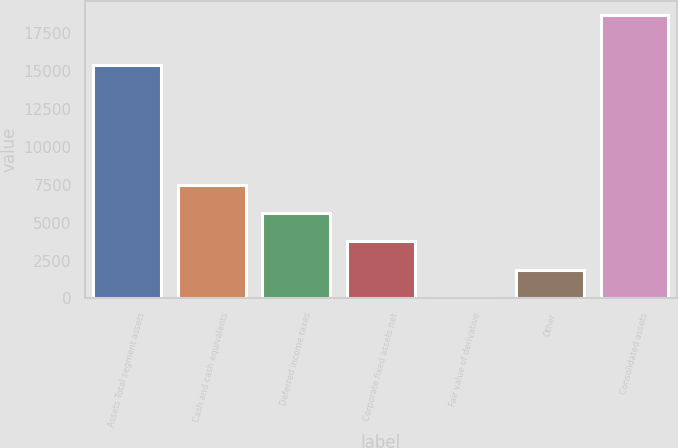Convert chart to OTSL. <chart><loc_0><loc_0><loc_500><loc_500><bar_chart><fcel>Assets Total segment assets<fcel>Cash and cash equivalents<fcel>Deferred income taxes<fcel>Corporate fixed assets net<fcel>Fair value of derivative<fcel>Other<fcel>Consolidated assets<nl><fcel>15369<fcel>7499.4<fcel>5633.8<fcel>3768.2<fcel>37<fcel>1902.6<fcel>18693<nl></chart> 